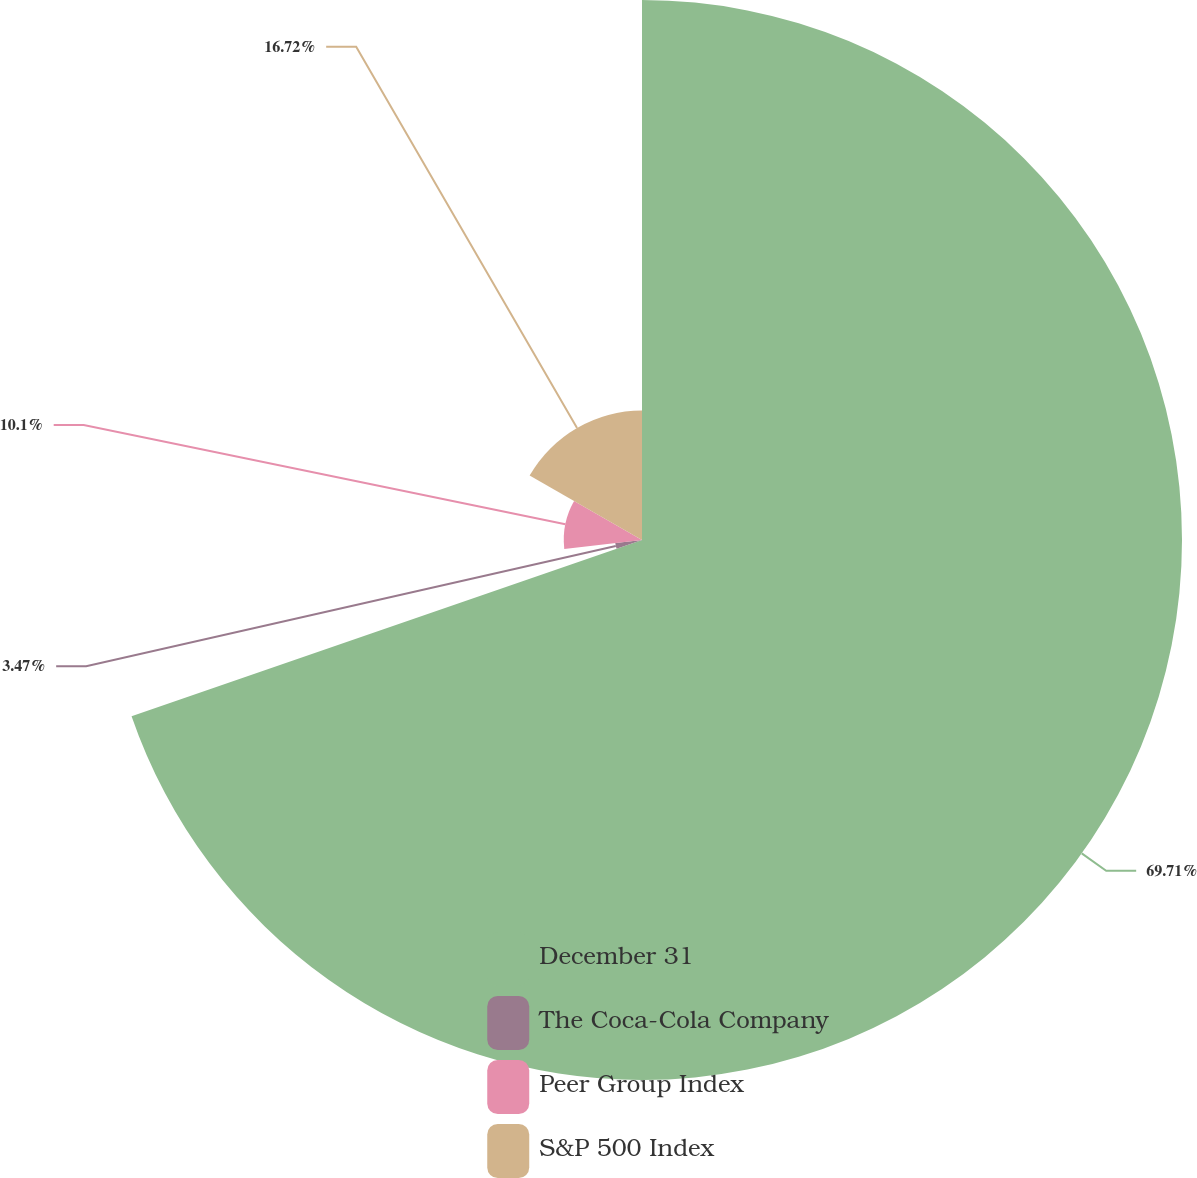Convert chart to OTSL. <chart><loc_0><loc_0><loc_500><loc_500><pie_chart><fcel>December 31<fcel>The Coca-Cola Company<fcel>Peer Group Index<fcel>S&P 500 Index<nl><fcel>69.71%<fcel>3.47%<fcel>10.1%<fcel>16.72%<nl></chart> 